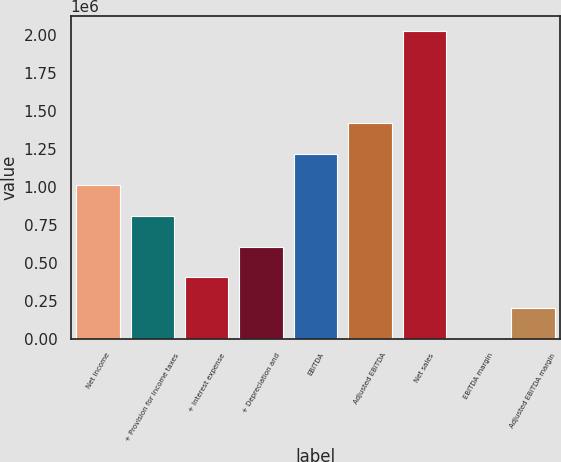<chart> <loc_0><loc_0><loc_500><loc_500><bar_chart><fcel>Net income<fcel>+ Provision for income taxes<fcel>+ Interest expense<fcel>+ Depreciation and<fcel>EBITDA<fcel>Adjusted EBITDA<fcel>Net sales<fcel>EBITDA margin<fcel>Adjusted EBITDA margin<nl><fcel>1.01208e+06<fcel>809666<fcel>404845<fcel>607255<fcel>1.21449e+06<fcel>1.4169e+06<fcel>2.02413e+06<fcel>23.5<fcel>202434<nl></chart> 